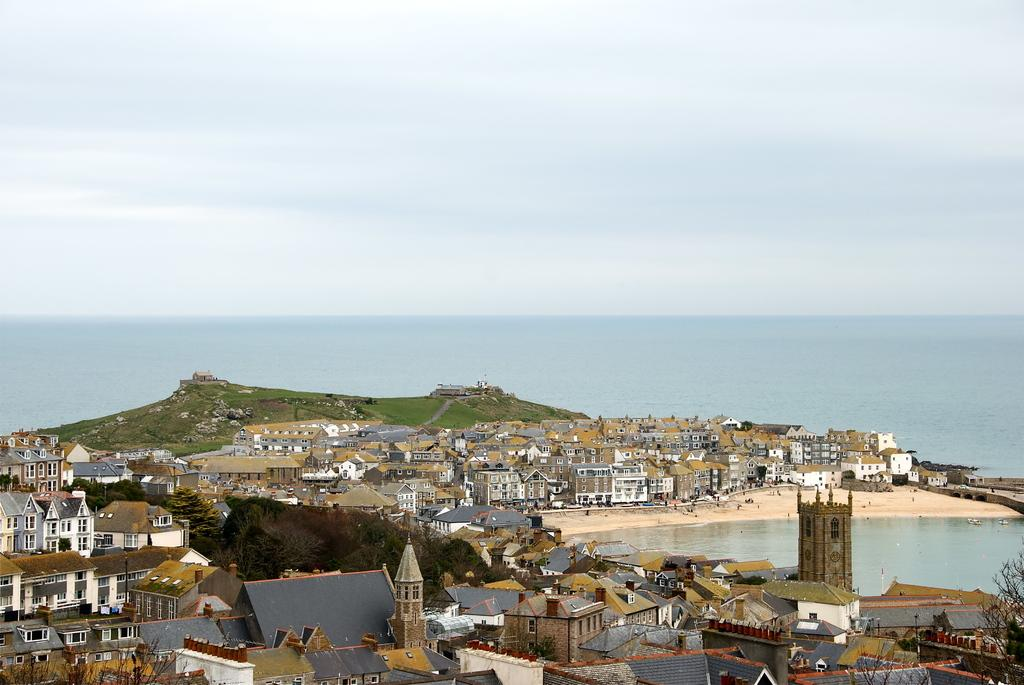What type of structures can be seen in the image? There are many buildings in the image. What feature do the buildings have? The buildings have windows. What natural elements are visible in the image? Water, sand, a tree, and grass are visible in the image. What part of the environment can be seen in the image? The sky is visible in the image. Are there any living beings present in the image? Yes, there are people in the image. What type of cherry is being used to decorate the lace on the van in the image? There is no cherry, lace, or van present in the image. 